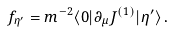<formula> <loc_0><loc_0><loc_500><loc_500>f _ { \eta ^ { \prime } } = m ^ { - 2 } \langle 0 | \partial _ { \mu } J ^ { ( 1 ) } | \eta ^ { \prime } \rangle \, .</formula> 